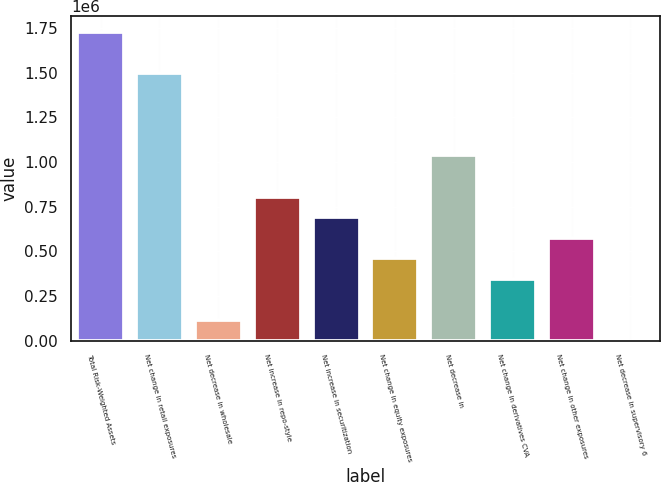Convert chart to OTSL. <chart><loc_0><loc_0><loc_500><loc_500><bar_chart><fcel>Total Risk-Weighted Assets<fcel>Net change in retail exposures<fcel>Net decrease in wholesale<fcel>Net increase in repo-style<fcel>Net increase in securitization<fcel>Net change in equity exposures<fcel>Net decrease in<fcel>Net change in derivatives CVA<fcel>Net change in other exposures<fcel>Net decrease in supervisory 6<nl><fcel>1.7287e+06<fcel>1.49828e+06<fcel>115750<fcel>807013<fcel>691802<fcel>461382<fcel>1.03743e+06<fcel>346171<fcel>576592<fcel>540<nl></chart> 